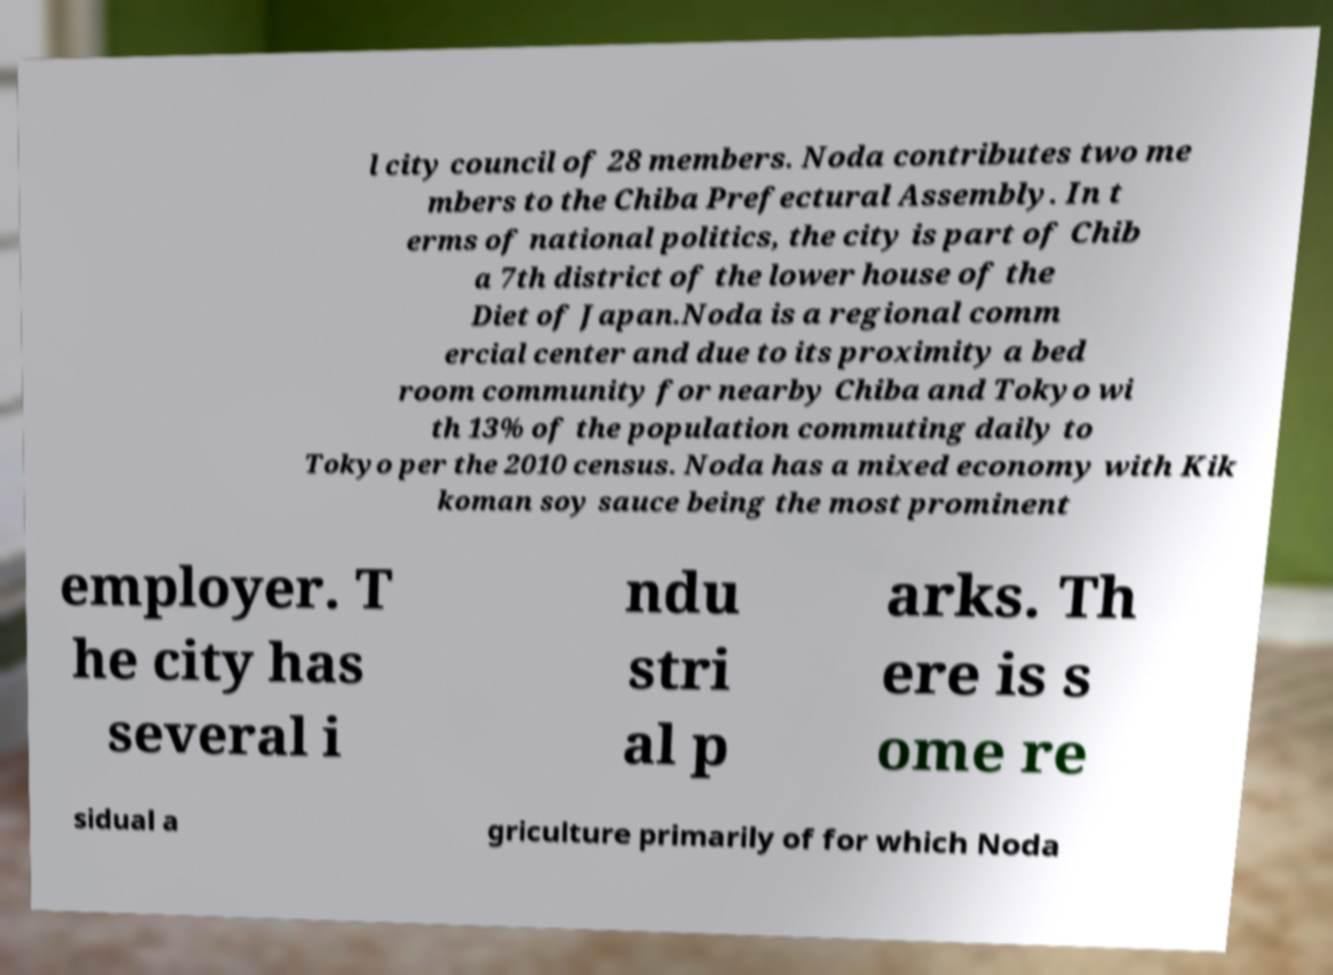There's text embedded in this image that I need extracted. Can you transcribe it verbatim? l city council of 28 members. Noda contributes two me mbers to the Chiba Prefectural Assembly. In t erms of national politics, the city is part of Chib a 7th district of the lower house of the Diet of Japan.Noda is a regional comm ercial center and due to its proximity a bed room community for nearby Chiba and Tokyo wi th 13% of the population commuting daily to Tokyo per the 2010 census. Noda has a mixed economy with Kik koman soy sauce being the most prominent employer. T he city has several i ndu stri al p arks. Th ere is s ome re sidual a griculture primarily of for which Noda 